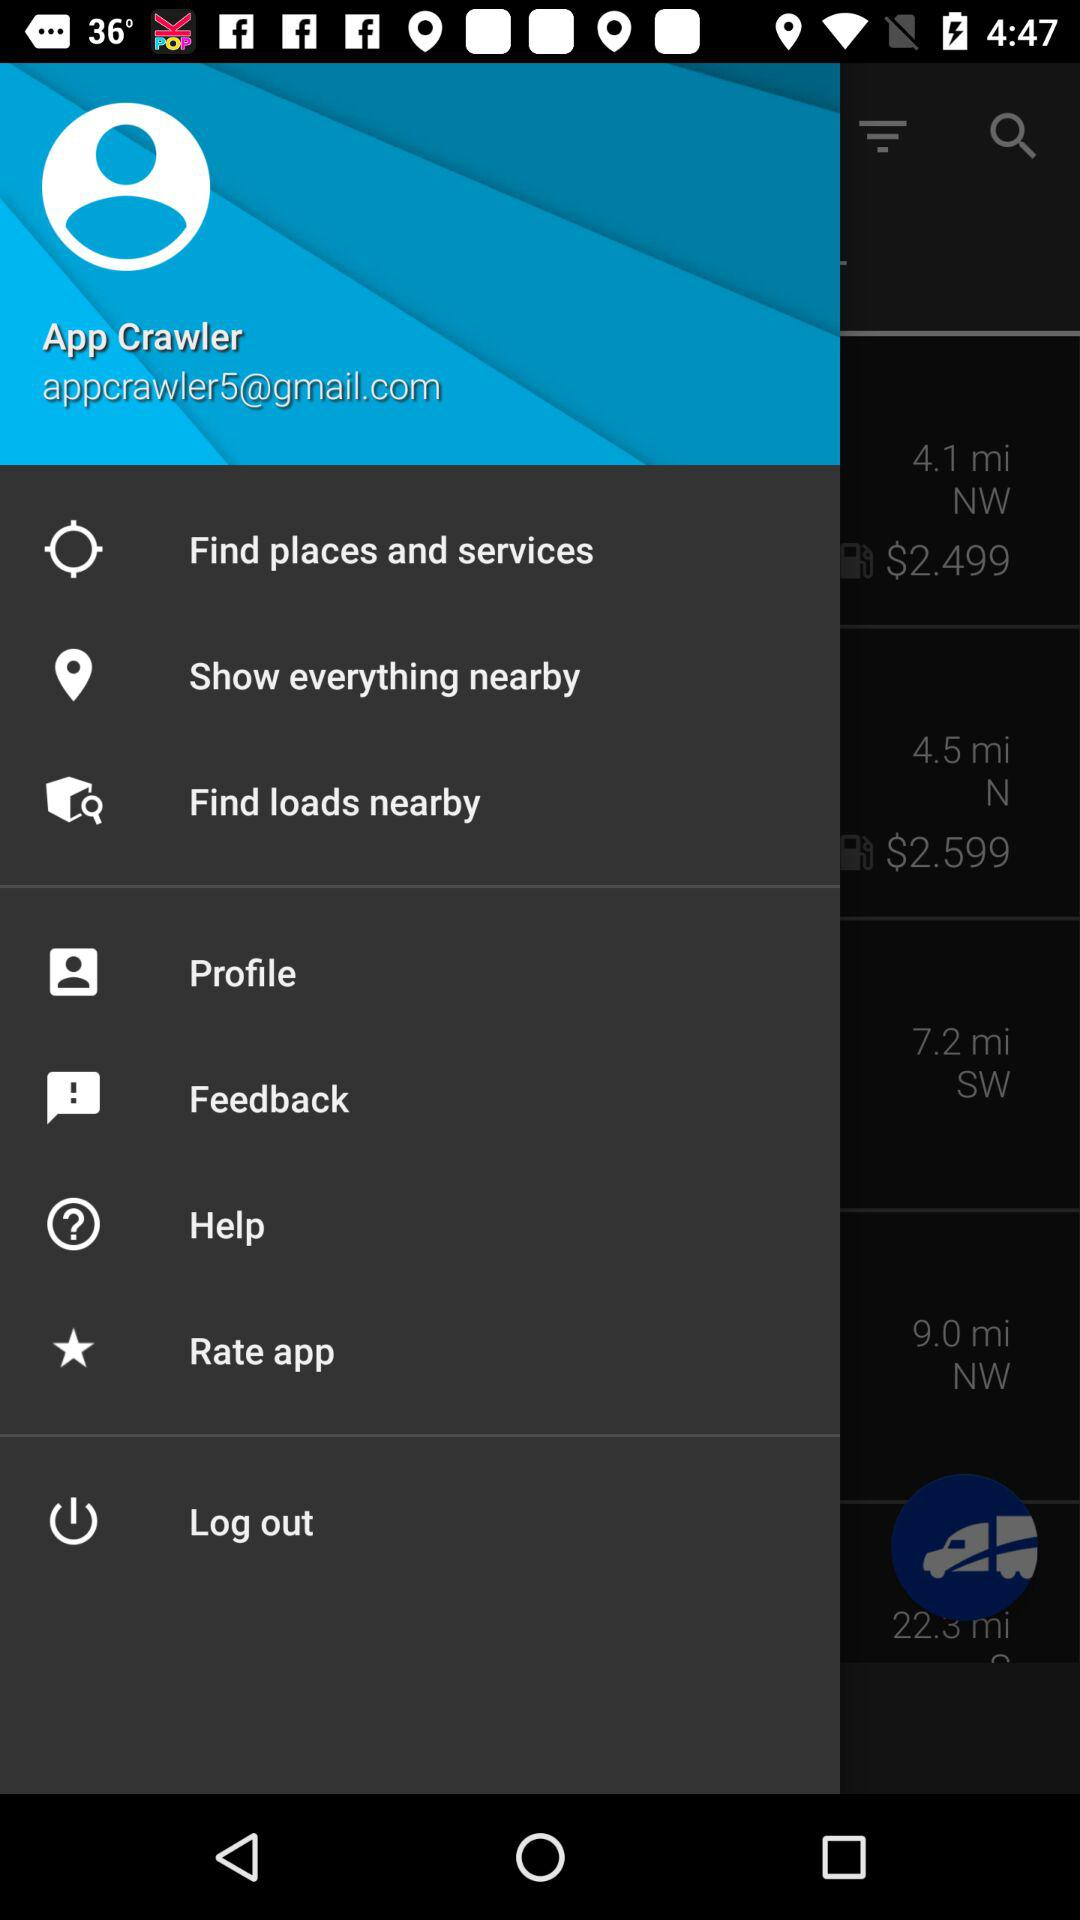What is the user's name? The user's name is App Crawler. 